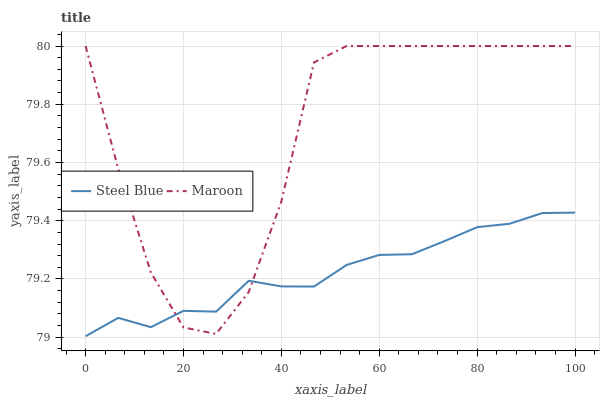Does Steel Blue have the minimum area under the curve?
Answer yes or no. Yes. Does Maroon have the maximum area under the curve?
Answer yes or no. Yes. Does Maroon have the minimum area under the curve?
Answer yes or no. No. Is Steel Blue the smoothest?
Answer yes or no. Yes. Is Maroon the roughest?
Answer yes or no. Yes. Is Maroon the smoothest?
Answer yes or no. No. Does Steel Blue have the lowest value?
Answer yes or no. Yes. Does Maroon have the lowest value?
Answer yes or no. No. Does Maroon have the highest value?
Answer yes or no. Yes. Does Maroon intersect Steel Blue?
Answer yes or no. Yes. Is Maroon less than Steel Blue?
Answer yes or no. No. Is Maroon greater than Steel Blue?
Answer yes or no. No. 